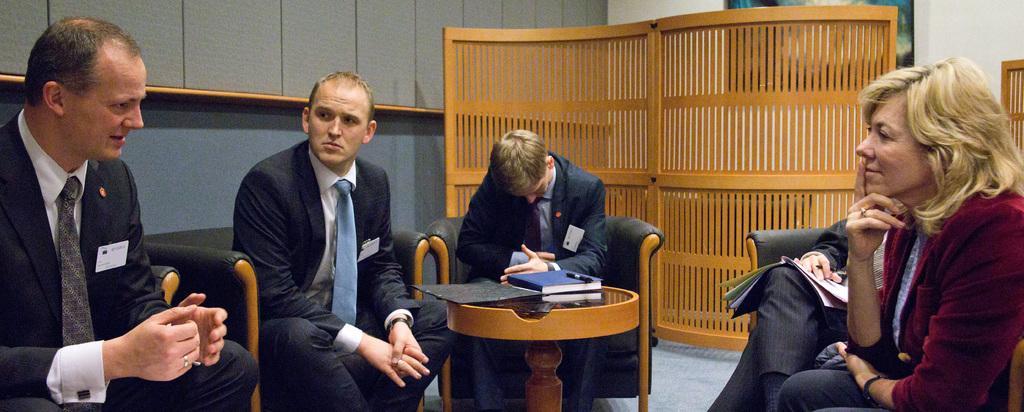Describe this image in one or two sentences. In this picture there are people sitting on chairs and we can see book, pen and object on the table. In the background of the image we can see frame on the wall and wooden objects. 